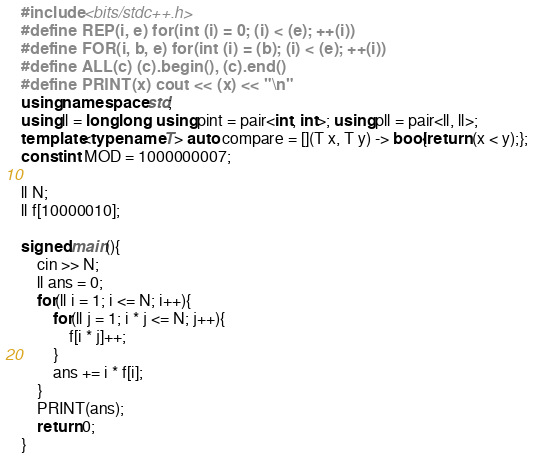Convert code to text. <code><loc_0><loc_0><loc_500><loc_500><_C++_>#include <bits/stdc++.h>
#define REP(i, e) for(int (i) = 0; (i) < (e); ++(i))
#define FOR(i, b, e) for(int (i) = (b); (i) < (e); ++(i))
#define ALL(c) (c).begin(), (c).end()
#define PRINT(x) cout << (x) << "\n"
using namespace std;
using ll = long long; using pint = pair<int, int>; using pll = pair<ll, ll>;
template<typename T> auto compare = [](T x, T y) -> bool{return (x < y);};
const int MOD = 1000000007;

ll N;
ll f[10000010];

signed main(){
    cin >> N;
    ll ans = 0;
    for(ll i = 1; i <= N; i++){
        for(ll j = 1; i * j <= N; j++){
            f[i * j]++;
        }
        ans += i * f[i];
    }
    PRINT(ans);
    return 0;
}</code> 